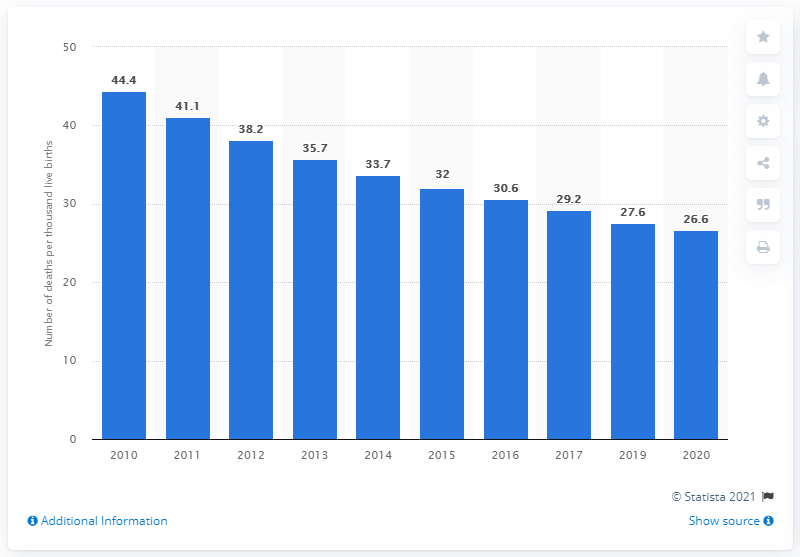Specify some key components in this picture. In 2019, the under-five child mortality rate in Cambodia was 26.6 deaths per 1,000 live births. 